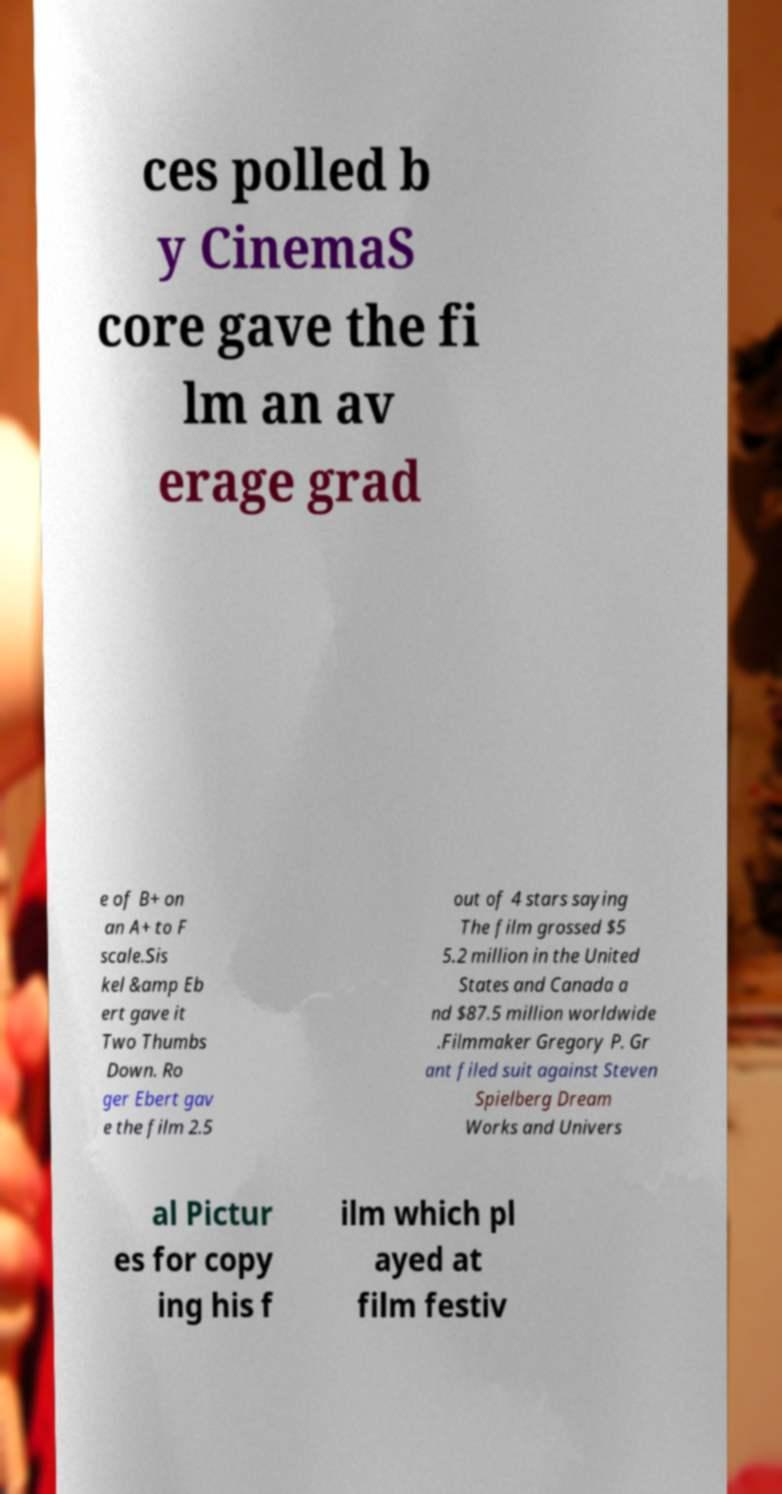I need the written content from this picture converted into text. Can you do that? ces polled b y CinemaS core gave the fi lm an av erage grad e of B+ on an A+ to F scale.Sis kel &amp Eb ert gave it Two Thumbs Down. Ro ger Ebert gav e the film 2.5 out of 4 stars saying The film grossed $5 5.2 million in the United States and Canada a nd $87.5 million worldwide .Filmmaker Gregory P. Gr ant filed suit against Steven Spielberg Dream Works and Univers al Pictur es for copy ing his f ilm which pl ayed at film festiv 